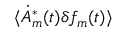Convert formula to latex. <formula><loc_0><loc_0><loc_500><loc_500>\langle \dot { A } _ { m } ^ { * } ( t ) \delta f _ { m } ( t ) \rangle</formula> 